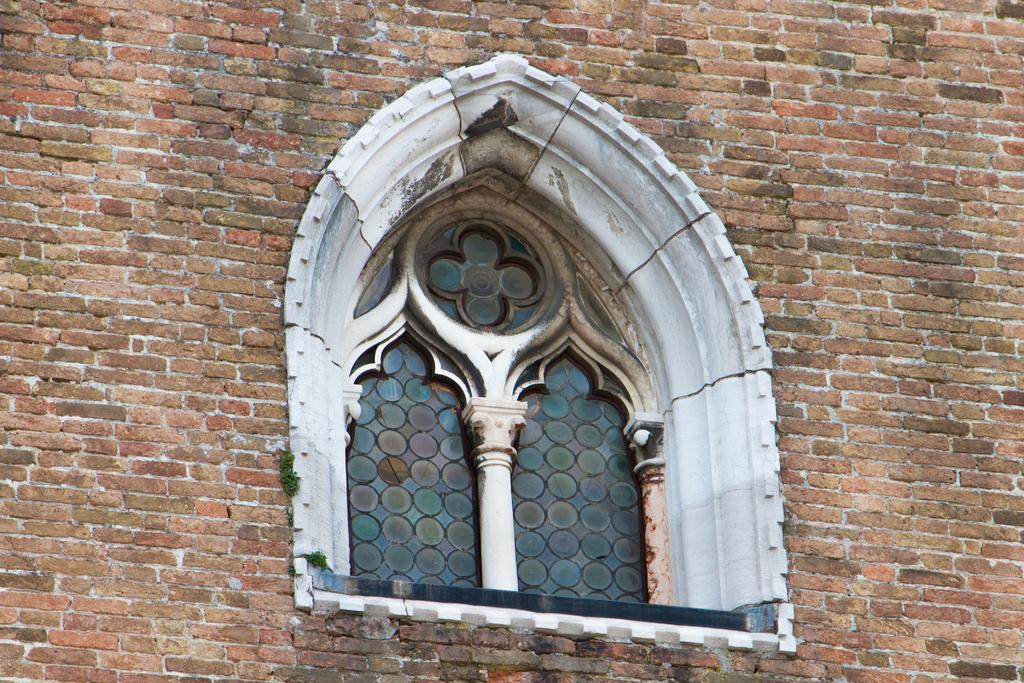What can be seen in the image? There is a wall in the image. What feature is present on the wall? There is a window in the wall. How many shelves can be seen in the image? There are no shelves present in the image; it only features a wall with a window. Is there a camp visible in the image? There is no camp present in the image; it only features a wall with a window. 